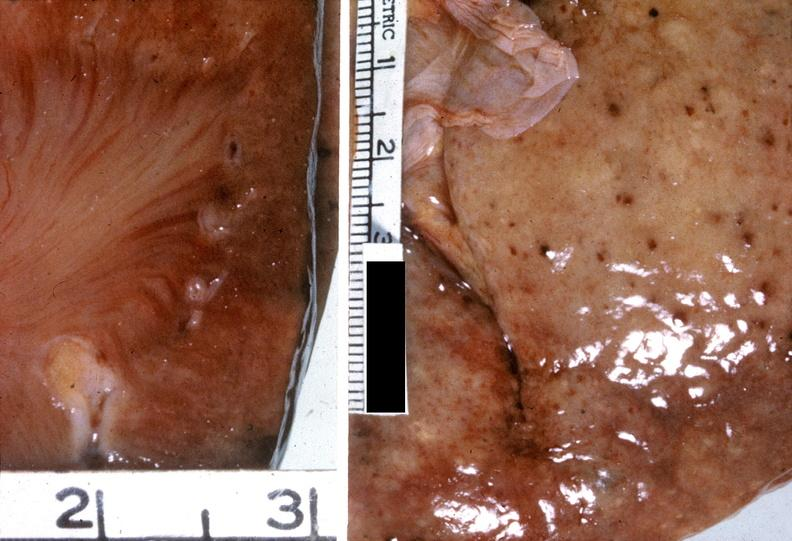does kidney, papillitis, show kidney, malignant hypertension?
Answer the question using a single word or phrase. No 